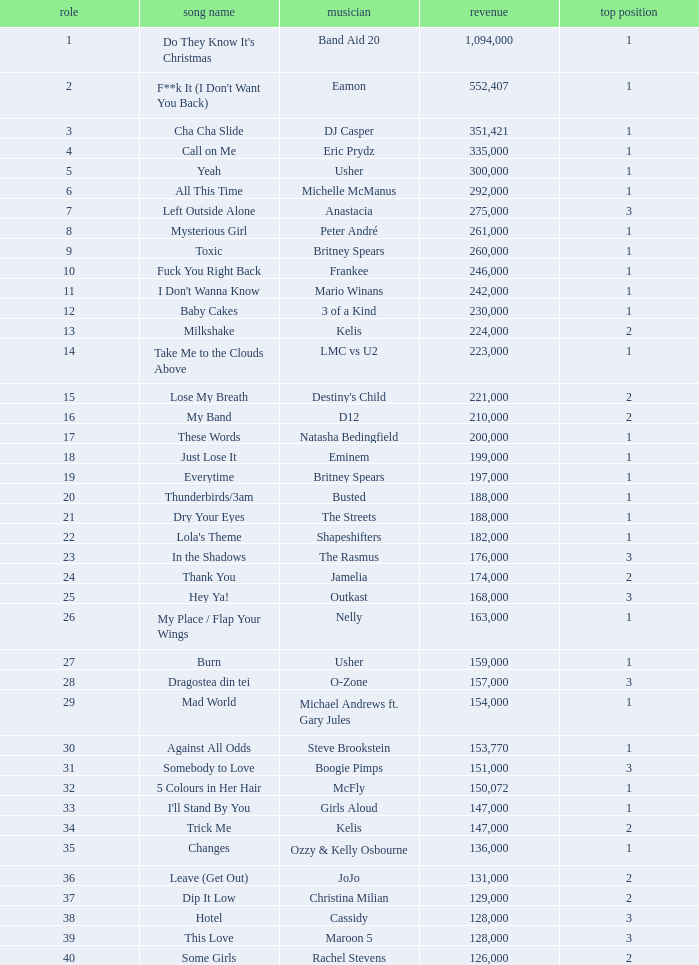What is the most sales by a song with a position higher than 3? None. 